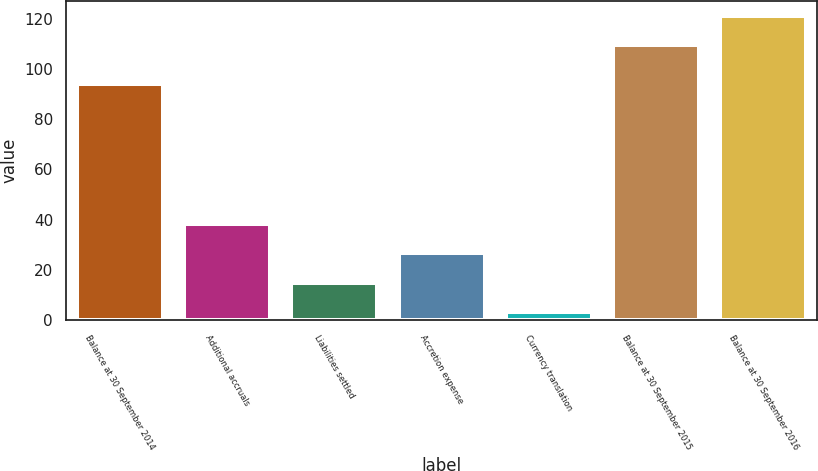<chart> <loc_0><loc_0><loc_500><loc_500><bar_chart><fcel>Balance at 30 September 2014<fcel>Additional accruals<fcel>Liabilities settled<fcel>Accretion expense<fcel>Currency translation<fcel>Balance at 30 September 2015<fcel>Balance at 30 September 2016<nl><fcel>94<fcel>38.28<fcel>14.96<fcel>26.62<fcel>3.3<fcel>109.4<fcel>121.06<nl></chart> 